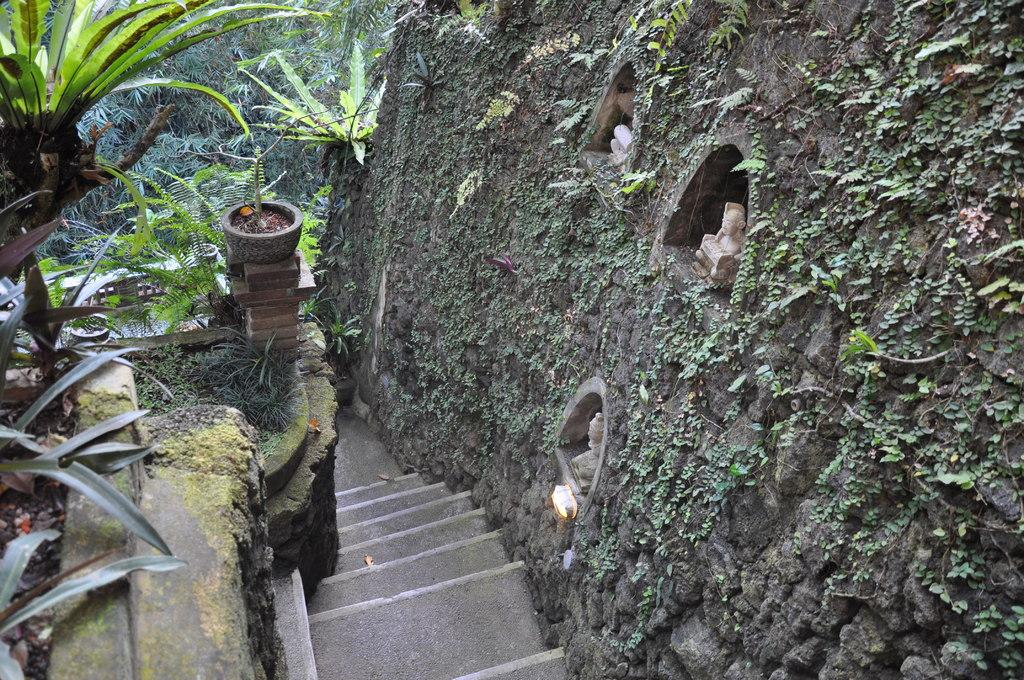What type of architectural feature can be seen in the image? There are steps in the image. What is located near the steps in the image? There is a wall in the image. What religious or cultural objects are present in the image? Idols are present in the image. What can be seen illuminating the scene in the image? There is light visible in the image. What type of vegetation is visible in the background of the image? Plants and trees are present in the background of the image. What type of underwear is visible on the idols in the image? There is no underwear visible on the idols in the image; they are religious or cultural objects and not people. How much sleet is present in the image? There is no sleet present in the image; it is not mentioned in the provided facts. 